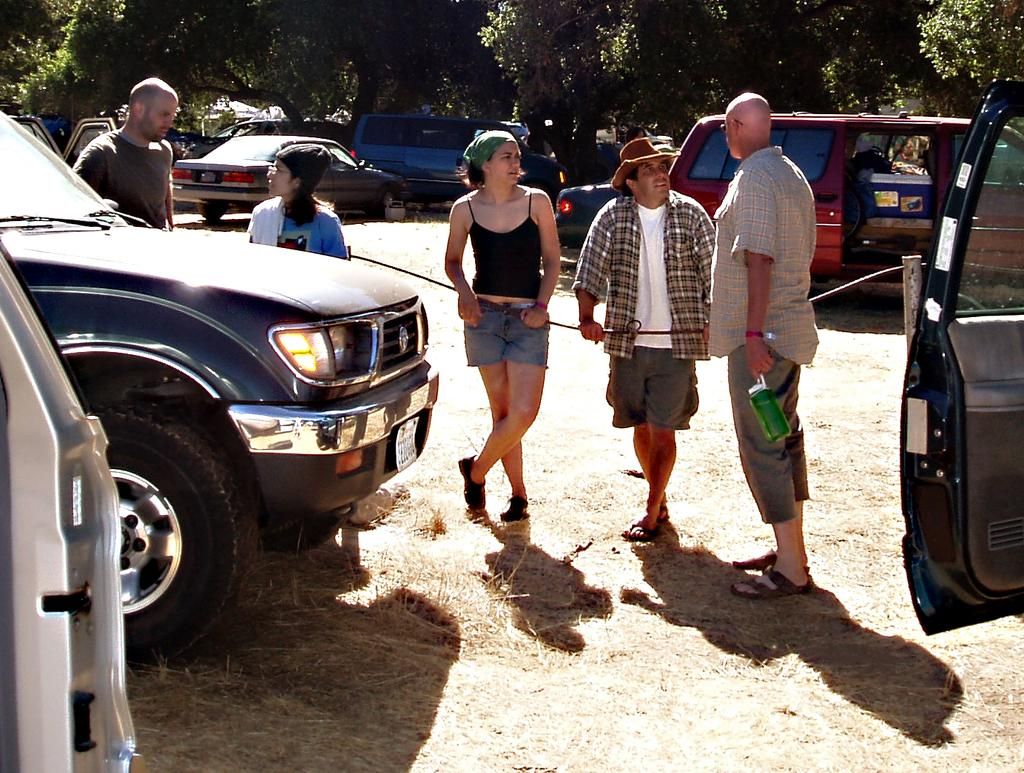What can be seen in the image in terms of vehicles? There are fleets of cars in the image. What else is present in the image besides the cars? There is a group of people standing on the ground in the image. What can be seen in the background of the image? There are trees and buildings in the background of the image. Can you determine the time of day the image was taken? The image is likely taken during the day, as there is no indication of darkness or artificial lighting. What is the name of the person making the statement in the image? There is no person making a statement in the image, as it does not contain any text or dialogue. 